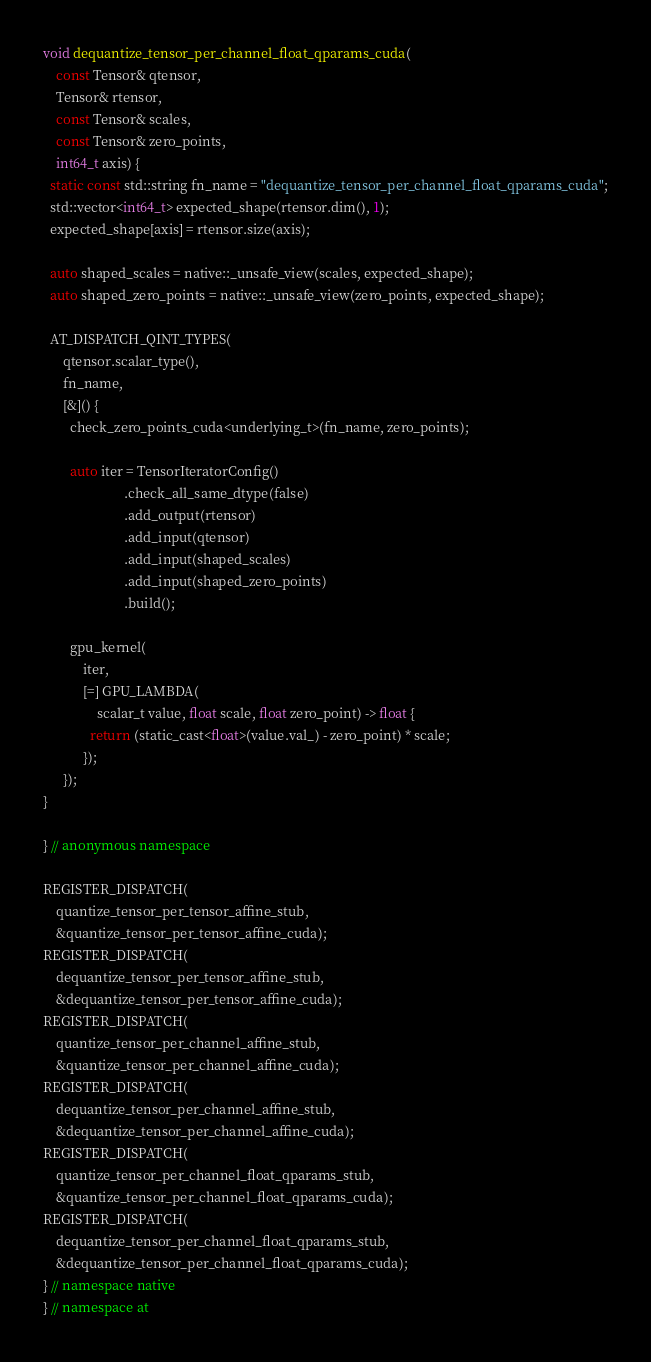<code> <loc_0><loc_0><loc_500><loc_500><_Cuda_>void dequantize_tensor_per_channel_float_qparams_cuda(
    const Tensor& qtensor,
    Tensor& rtensor,
    const Tensor& scales,
    const Tensor& zero_points,
    int64_t axis) {
  static const std::string fn_name = "dequantize_tensor_per_channel_float_qparams_cuda";
  std::vector<int64_t> expected_shape(rtensor.dim(), 1);
  expected_shape[axis] = rtensor.size(axis);

  auto shaped_scales = native::_unsafe_view(scales, expected_shape);
  auto shaped_zero_points = native::_unsafe_view(zero_points, expected_shape);

  AT_DISPATCH_QINT_TYPES(
      qtensor.scalar_type(),
      fn_name,
      [&]() {
        check_zero_points_cuda<underlying_t>(fn_name, zero_points);

        auto iter = TensorIteratorConfig()
                        .check_all_same_dtype(false)
                        .add_output(rtensor)
                        .add_input(qtensor)
                        .add_input(shaped_scales)
                        .add_input(shaped_zero_points)
                        .build();

        gpu_kernel(
            iter,
            [=] GPU_LAMBDA(
                scalar_t value, float scale, float zero_point) -> float {
              return (static_cast<float>(value.val_) - zero_point) * scale;
            });
      });
}

} // anonymous namespace

REGISTER_DISPATCH(
    quantize_tensor_per_tensor_affine_stub,
    &quantize_tensor_per_tensor_affine_cuda);
REGISTER_DISPATCH(
    dequantize_tensor_per_tensor_affine_stub,
    &dequantize_tensor_per_tensor_affine_cuda);
REGISTER_DISPATCH(
    quantize_tensor_per_channel_affine_stub,
    &quantize_tensor_per_channel_affine_cuda);
REGISTER_DISPATCH(
    dequantize_tensor_per_channel_affine_stub,
    &dequantize_tensor_per_channel_affine_cuda);
REGISTER_DISPATCH(
    quantize_tensor_per_channel_float_qparams_stub,
    &quantize_tensor_per_channel_float_qparams_cuda);
REGISTER_DISPATCH(
    dequantize_tensor_per_channel_float_qparams_stub,
    &dequantize_tensor_per_channel_float_qparams_cuda);
} // namespace native
} // namespace at
</code> 